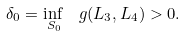Convert formula to latex. <formula><loc_0><loc_0><loc_500><loc_500>\delta _ { 0 } = \inf _ { \, S _ { 0 } } \, \ g ( L _ { 3 } , L _ { 4 } ) > 0 .</formula> 